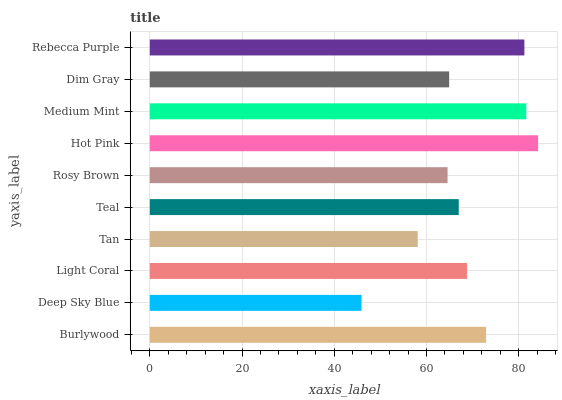Is Deep Sky Blue the minimum?
Answer yes or no. Yes. Is Hot Pink the maximum?
Answer yes or no. Yes. Is Light Coral the minimum?
Answer yes or no. No. Is Light Coral the maximum?
Answer yes or no. No. Is Light Coral greater than Deep Sky Blue?
Answer yes or no. Yes. Is Deep Sky Blue less than Light Coral?
Answer yes or no. Yes. Is Deep Sky Blue greater than Light Coral?
Answer yes or no. No. Is Light Coral less than Deep Sky Blue?
Answer yes or no. No. Is Light Coral the high median?
Answer yes or no. Yes. Is Teal the low median?
Answer yes or no. Yes. Is Tan the high median?
Answer yes or no. No. Is Tan the low median?
Answer yes or no. No. 